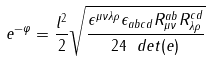<formula> <loc_0><loc_0><loc_500><loc_500>e ^ { - \varphi } = \frac { l ^ { 2 } } { 2 } \sqrt { \frac { \epsilon ^ { \mu \nu \lambda \rho } \epsilon _ { a b c d } R ^ { a b } _ { \mu \nu } R ^ { c d } _ { \lambda \rho } } { 2 4 \ d e t ( e ) } }</formula> 